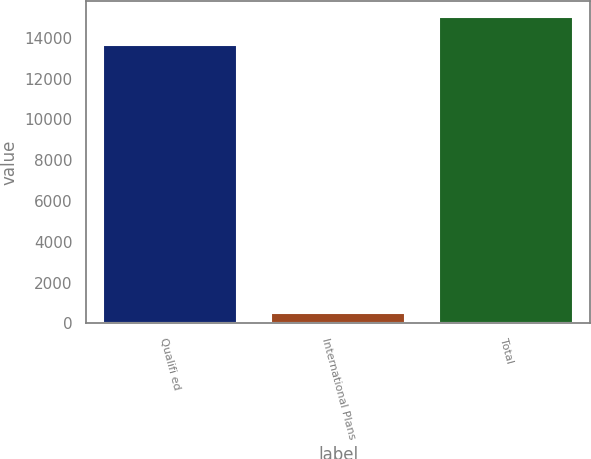Convert chart. <chart><loc_0><loc_0><loc_500><loc_500><bar_chart><fcel>Qualifi ed<fcel>International Plans<fcel>Total<nl><fcel>13635<fcel>501<fcel>15033.3<nl></chart> 